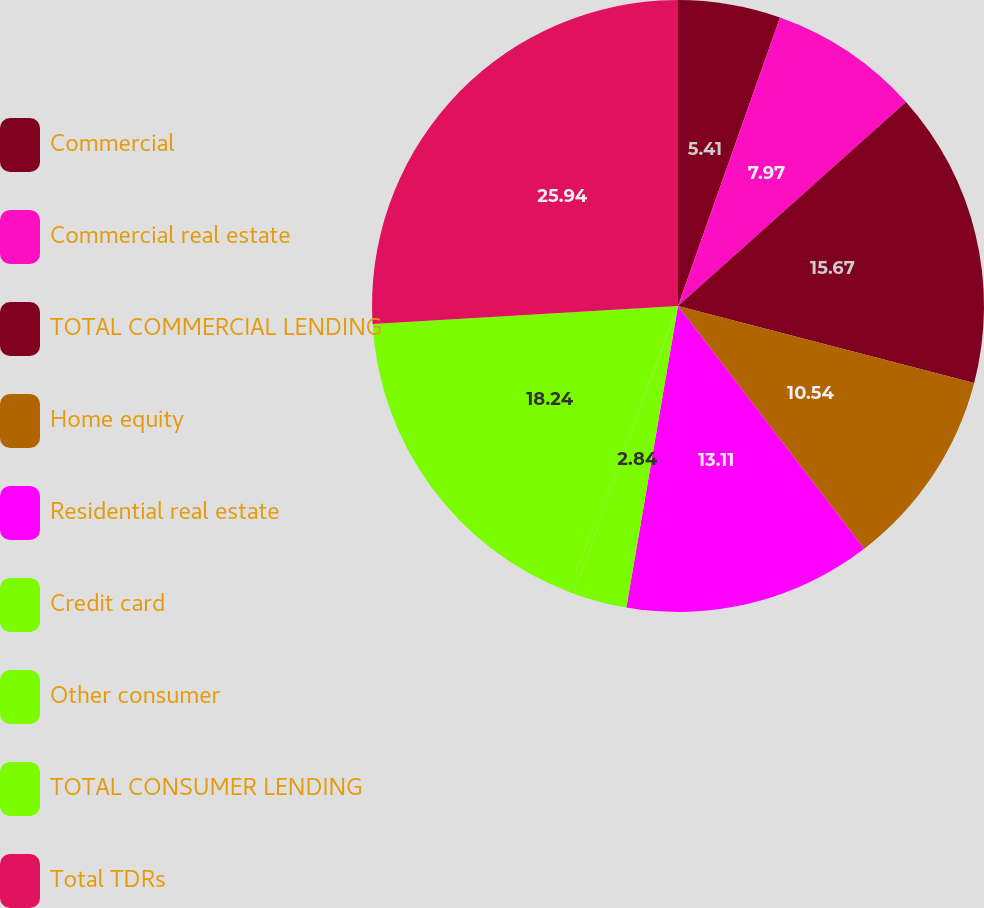Convert chart to OTSL. <chart><loc_0><loc_0><loc_500><loc_500><pie_chart><fcel>Commercial<fcel>Commercial real estate<fcel>TOTAL COMMERCIAL LENDING<fcel>Home equity<fcel>Residential real estate<fcel>Credit card<fcel>Other consumer<fcel>TOTAL CONSUMER LENDING<fcel>Total TDRs<nl><fcel>5.41%<fcel>7.97%<fcel>15.67%<fcel>10.54%<fcel>13.11%<fcel>2.84%<fcel>0.28%<fcel>18.24%<fcel>25.94%<nl></chart> 